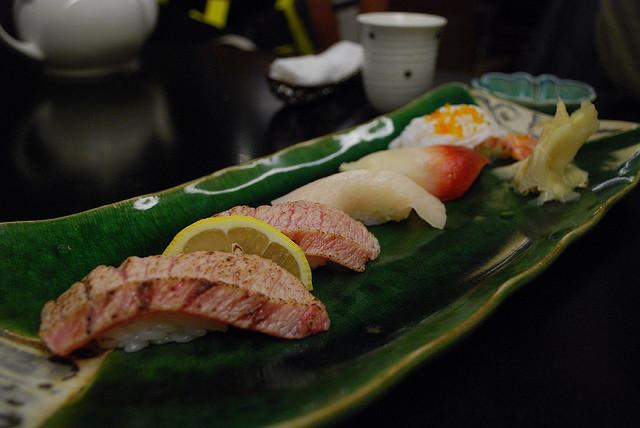Why would someone sit at this table? Please explain your reasoning. to eat. The person would want to eat the sushi. 